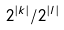Convert formula to latex. <formula><loc_0><loc_0><loc_500><loc_500>2 ^ { | k | } / 2 ^ { | l | }</formula> 